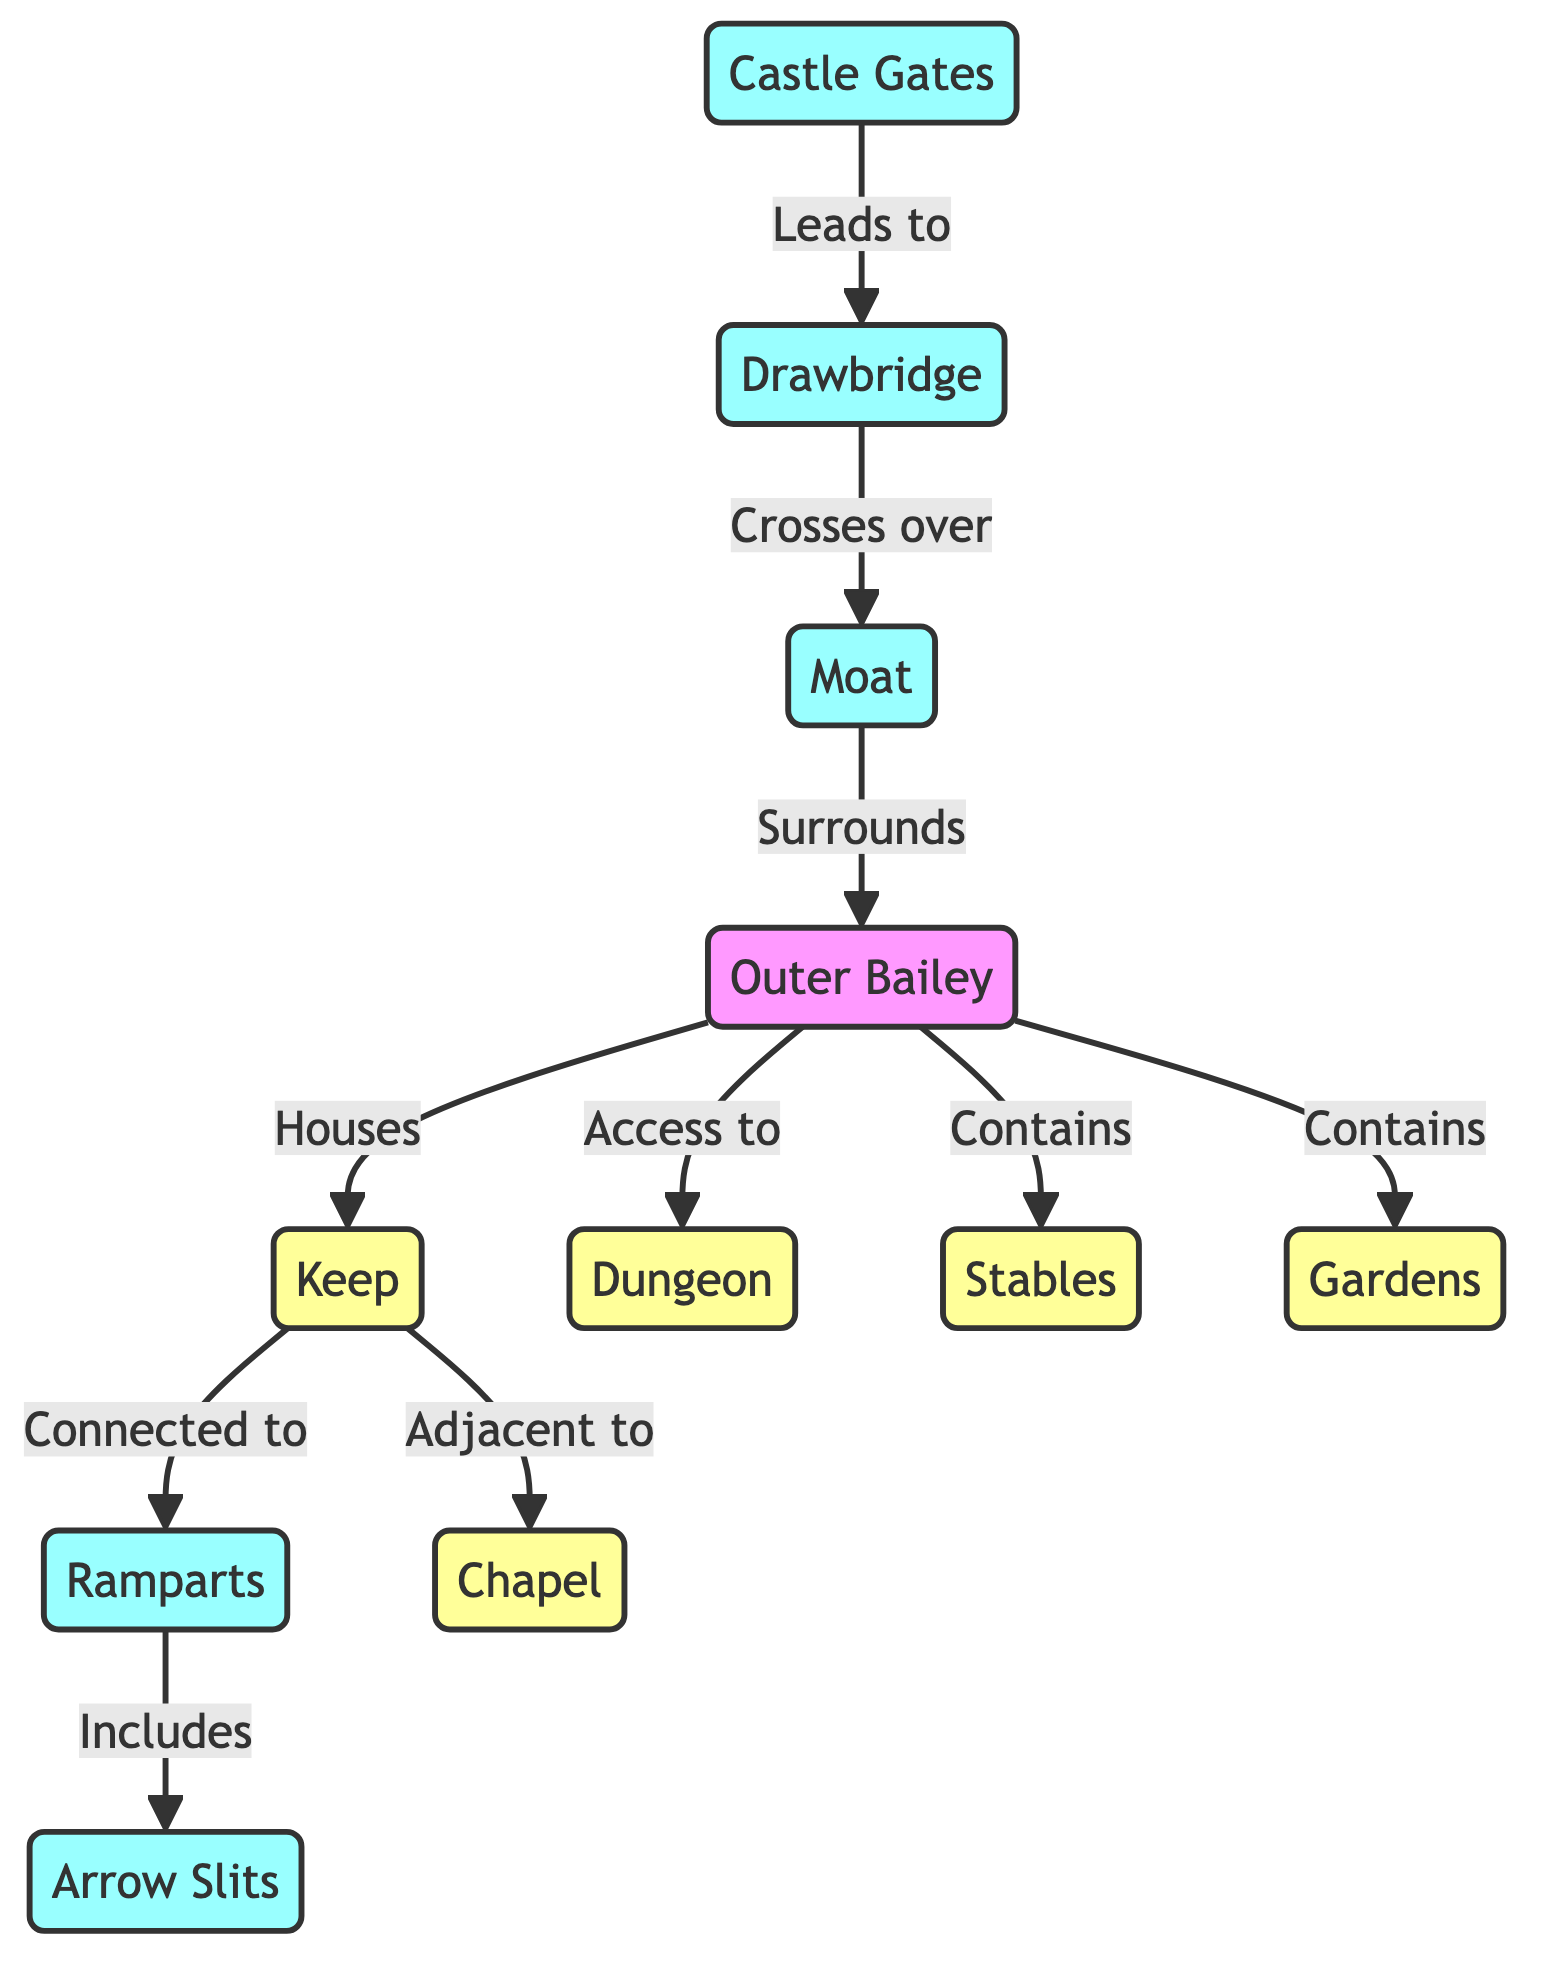What structure is adjacent to the keep? The diagram shows that the keep is connected to the chapel, indicating a direct relationship between these two structures.
Answer: chapel What structure is located within the bailey? The diagram indicates that the bailey houses multiple structures, including the keep, dungeon, stables, and gardens. Since we are looking for any structure within, we can refer to all of them, but specifically, the dungeon is highlighted in its own connection to the bailey.
Answer: dungeon How many outer nodes are depicted in the diagram? The outer nodes in the diagram are the castle gates, drawbridge, moat, ramparts, and arrow slits. Counting these nodes gives us a total of five.
Answer: 5 What does the moat surround? According to the diagram, the moat surrounds the bailey, indicating its protective function around this area of the castle.
Answer: bailey What is the primary function of the drawbridge? The diagram states that the drawbridge crosses over the moat, implying its role in providing access while also serving as a defensive mechanism when raised.
Answer: access Which structure provides access to the dungeon? The diagram shows that the bailey provides access to the dungeon, detailing the relationship between these two castle features.
Answer: bailey What element is included in the ramparts? The ramparts are depicted as including arrow slits in the diagram, serving a strategic defensive purpose by allowing archers to shoot while providing cover.
Answer: arrow slits Which two structures are located within the bailey? The diagram clearly indicates that the bailey contains both stables and gardens, amongst other structures, showcasing its multifunctional role.
Answer: stables and gardens What connects the keep to other structures? The diagram reveals that the keep is connected to the ramparts and adjacent to the chapel, illustrating its placement within the castle's defensive layout.
Answer: ramparts and chapel 